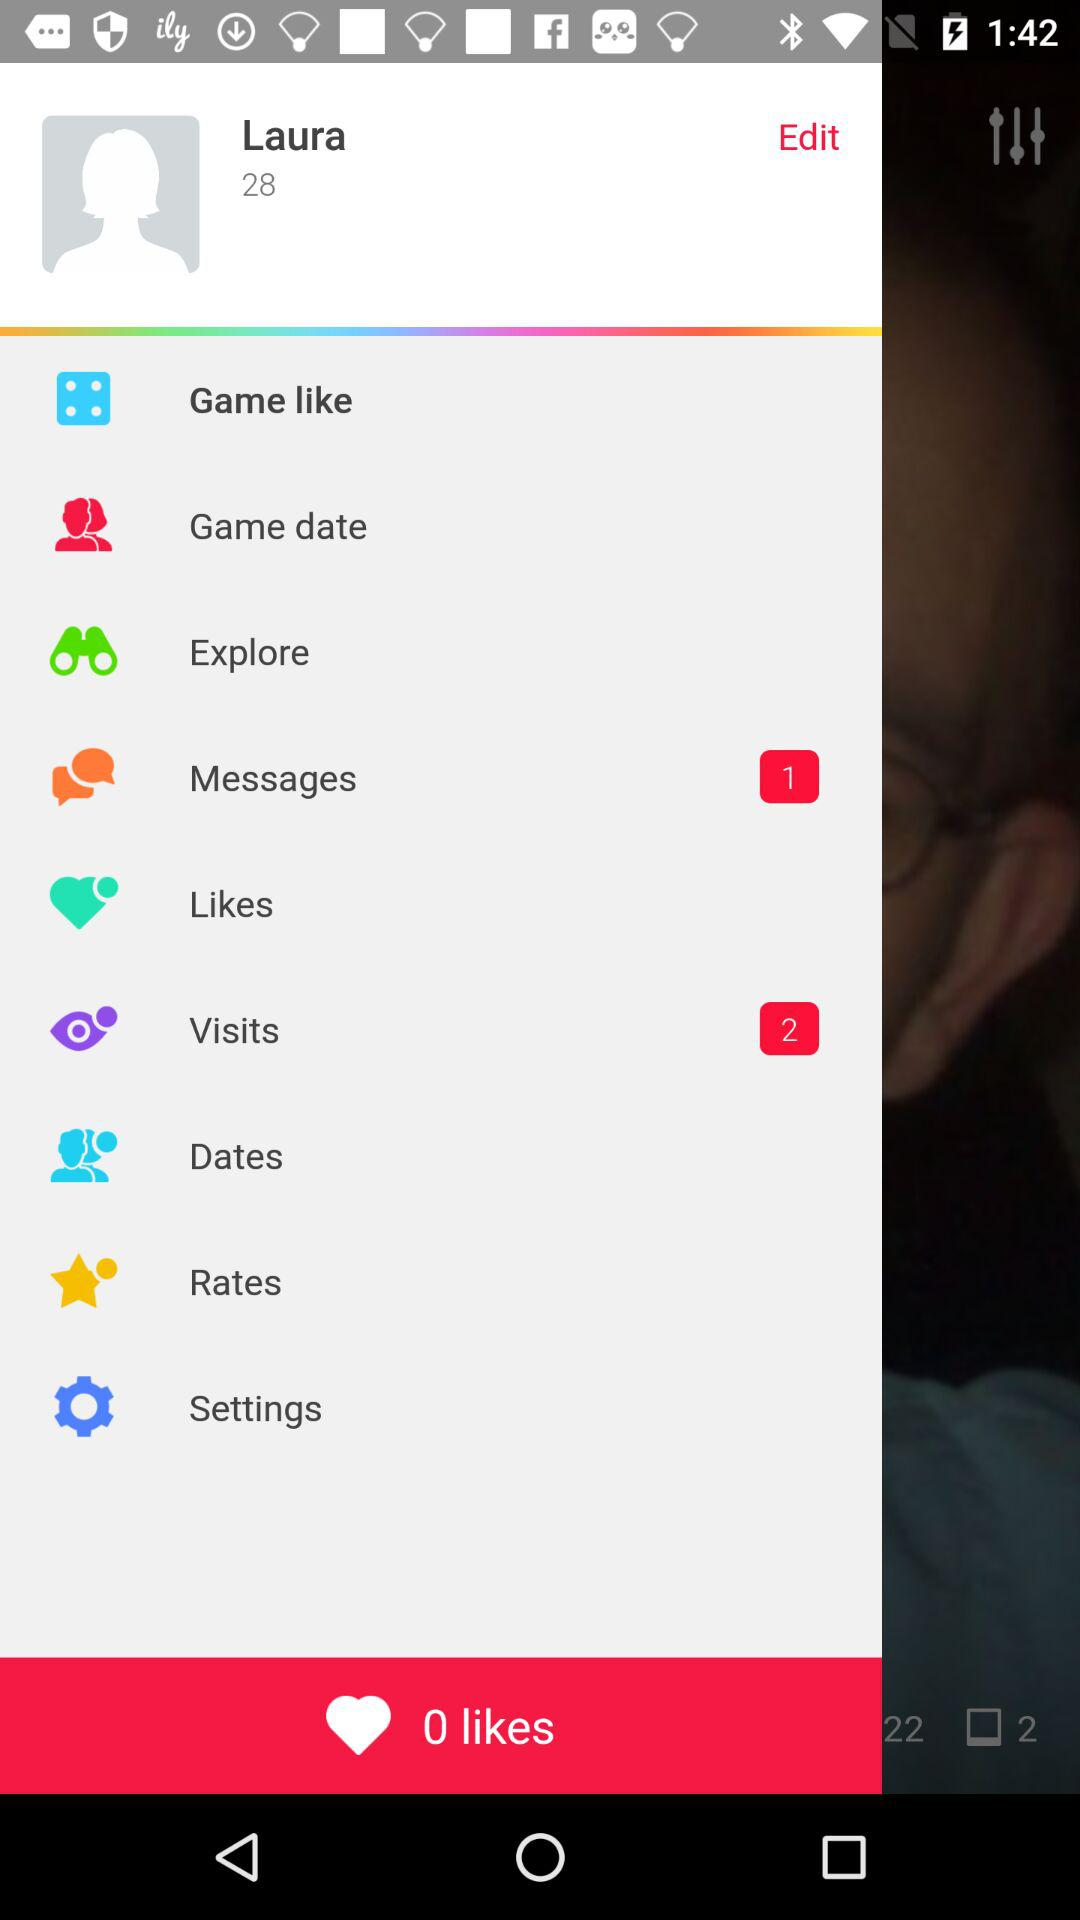How many total visits on the profile? The total visits are 2. 